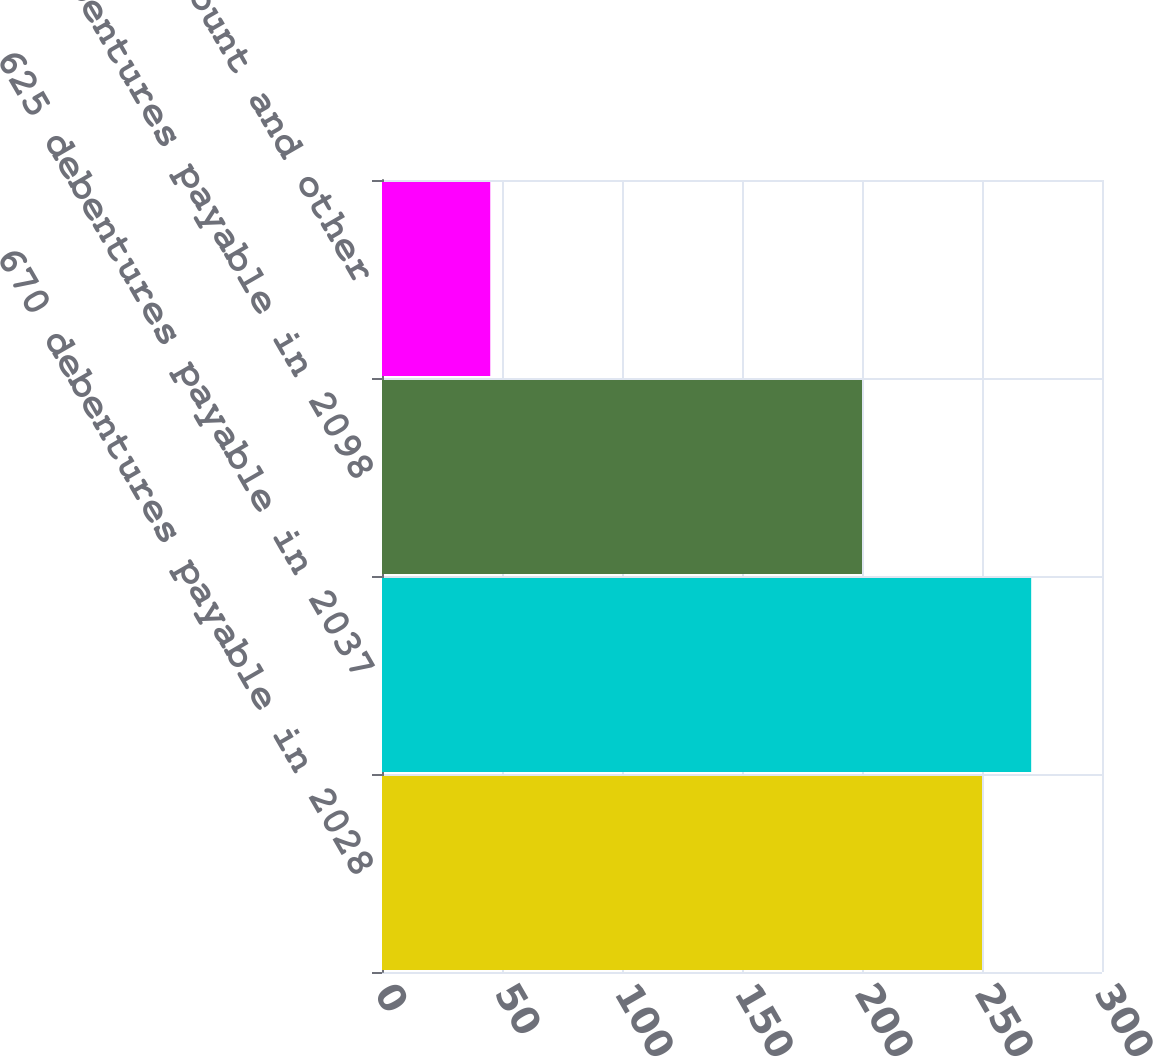Convert chart to OTSL. <chart><loc_0><loc_0><loc_500><loc_500><bar_chart><fcel>670 debentures payable in 2028<fcel>625 debentures payable in 2037<fcel>520 debentures payable in 2098<fcel>Unamortized discount and other<nl><fcel>250<fcel>270.49<fcel>200<fcel>45.1<nl></chart> 